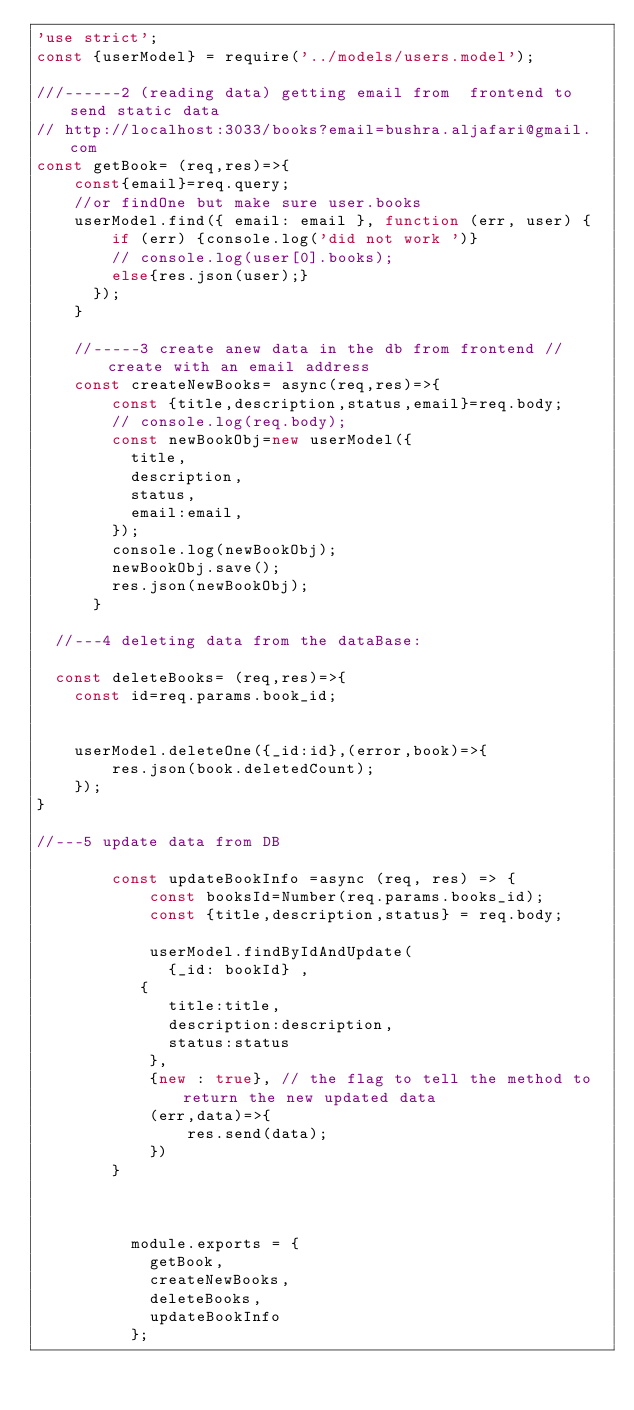Convert code to text. <code><loc_0><loc_0><loc_500><loc_500><_JavaScript_>'use strict';
const {userModel} = require('../models/users.model');

///------2 (reading data) getting email from  frontend to send static data
// http://localhost:3033/books?email=bushra.aljafari@gmail.com
const getBook= (req,res)=>{
    const{email}=req.query;
    //or findOne but make sure user.books
    userModel.find({ email: email }, function (err, user) {
        if (err) {console.log('did not work ')}
        // console.log(user[0].books);
        else{res.json(user);}  
      });
    }

    //-----3 create anew data in the db from frontend //create with an email address
    const createNewBooks= async(req,res)=>{
        const {title,description,status,email}=req.body;
        // console.log(req.body);
        const newBookObj=new userModel({
          title,
          description,
          status,
          email:email,
        });
        console.log(newBookObj);
        newBookObj.save();
        res.json(newBookObj);
      }

  //---4 deleting data from the dataBase:
  
  const deleteBooks= (req,res)=>{
    const id=req.params.book_id;
    

    userModel.deleteOne({_id:id},(error,book)=>{
        res.json(book.deletedCount);
    });
}

//---5 update data from DB

        const updateBookInfo =async (req, res) => {
            const booksId=Number(req.params.books_id);
            const {title,description,status} = req.body;
            
            userModel.findByIdAndUpdate(
              {_id: bookId} ,
           {
              title:title,
              description:description,
              status:status
            },
            {new : true}, // the flag to tell the method to return the new updated data
            (err,data)=>{
                res.send(data);
            })
        }
        
            

          module.exports = {
            getBook,
            createNewBooks,
            deleteBooks,
            updateBookInfo
          };
       </code> 